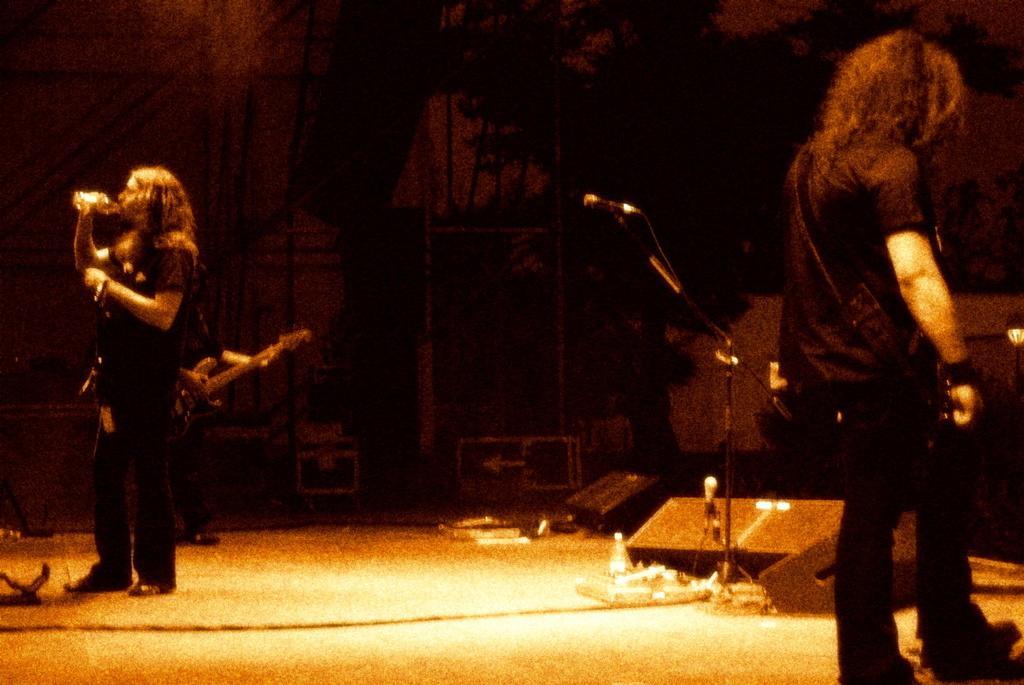In one or two sentences, can you explain what this image depicts? In this picture I see 2 men who are standing and I see the man on the left is holding a thing near to his mouth. In the middle of this picture I see a tripod on which there is a mic and I see few equipment on the ground. In the background I see that it is a bit dark. 